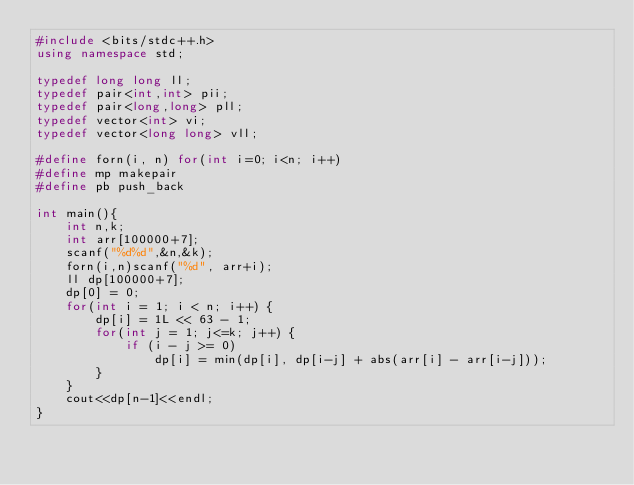Convert code to text. <code><loc_0><loc_0><loc_500><loc_500><_C++_>#include <bits/stdc++.h>
using namespace std;

typedef long long ll;
typedef pair<int,int> pii;
typedef pair<long,long> pll;
typedef vector<int> vi;
typedef vector<long long> vll;

#define forn(i, n) for(int i=0; i<n; i++)
#define mp makepair
#define pb push_back

int main(){
    int n,k;
    int arr[100000+7];
    scanf("%d%d",&n,&k);
    forn(i,n)scanf("%d", arr+i);
    ll dp[100000+7];
    dp[0] = 0;
    for(int i = 1; i < n; i++) {
        dp[i] = 1L << 63 - 1;
        for(int j = 1; j<=k; j++) {
            if (i - j >= 0)
                dp[i] = min(dp[i], dp[i-j] + abs(arr[i] - arr[i-j]));
        }
    }
    cout<<dp[n-1]<<endl;
}
</code> 